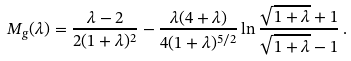Convert formula to latex. <formula><loc_0><loc_0><loc_500><loc_500>M _ { g } ( \lambda ) = { \frac { \lambda - 2 } { 2 ( 1 + \lambda ) ^ { 2 } } } - { \frac { \lambda ( 4 + \lambda ) } { 4 ( 1 + \lambda ) ^ { 5 / 2 } } } \ln { \frac { \sqrt { 1 + \lambda } + 1 } { \sqrt { 1 + \lambda } - 1 } } \, .</formula> 